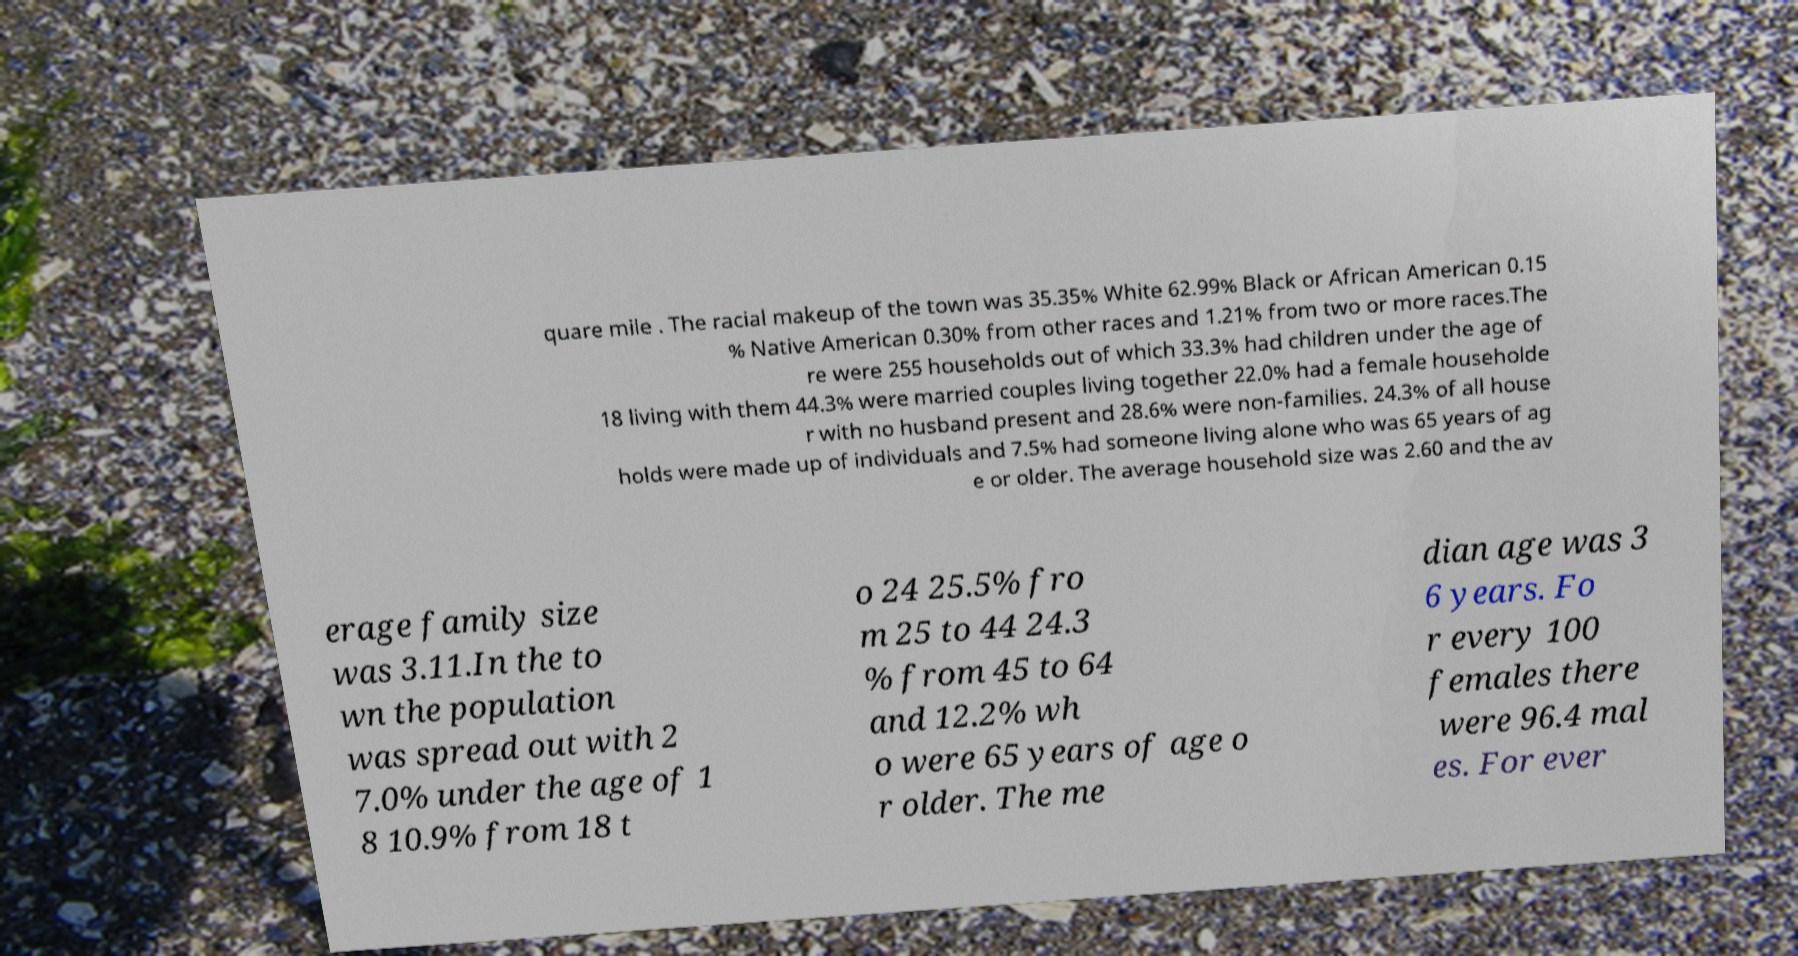There's text embedded in this image that I need extracted. Can you transcribe it verbatim? quare mile . The racial makeup of the town was 35.35% White 62.99% Black or African American 0.15 % Native American 0.30% from other races and 1.21% from two or more races.The re were 255 households out of which 33.3% had children under the age of 18 living with them 44.3% were married couples living together 22.0% had a female householde r with no husband present and 28.6% were non-families. 24.3% of all house holds were made up of individuals and 7.5% had someone living alone who was 65 years of ag e or older. The average household size was 2.60 and the av erage family size was 3.11.In the to wn the population was spread out with 2 7.0% under the age of 1 8 10.9% from 18 t o 24 25.5% fro m 25 to 44 24.3 % from 45 to 64 and 12.2% wh o were 65 years of age o r older. The me dian age was 3 6 years. Fo r every 100 females there were 96.4 mal es. For ever 